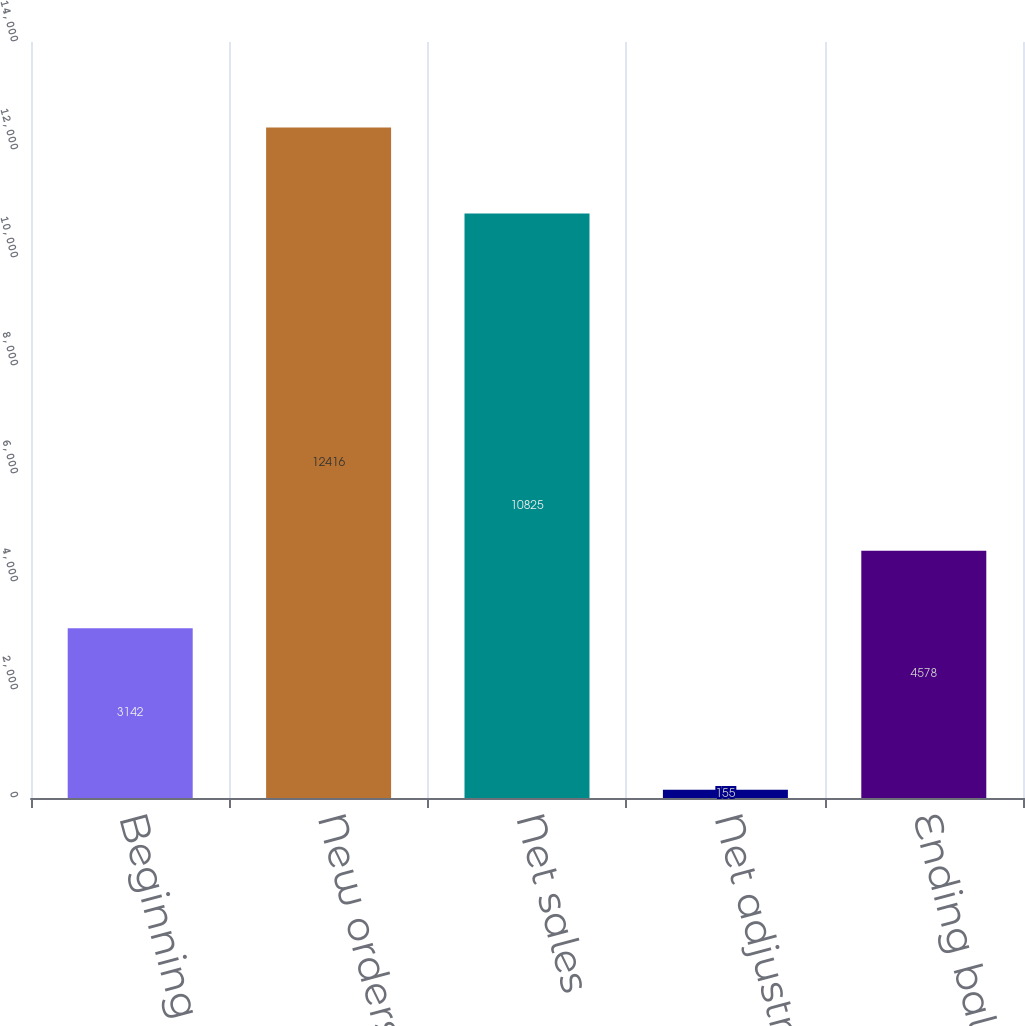<chart> <loc_0><loc_0><loc_500><loc_500><bar_chart><fcel>Beginning balance<fcel>New orders<fcel>Net sales<fcel>Net adjustments<fcel>Ending balance<nl><fcel>3142<fcel>12416<fcel>10825<fcel>155<fcel>4578<nl></chart> 